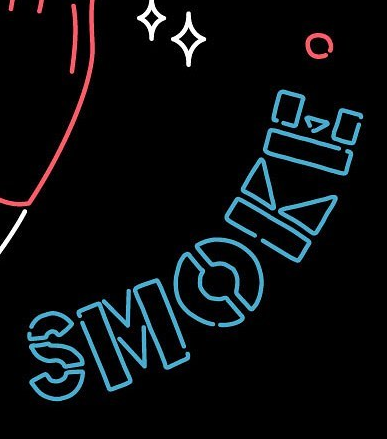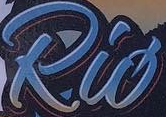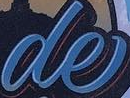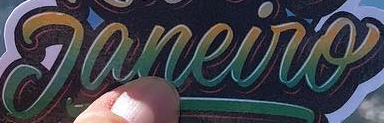Read the text content from these images in order, separated by a semicolon. SMOKE; Rió; de; Janeiro 